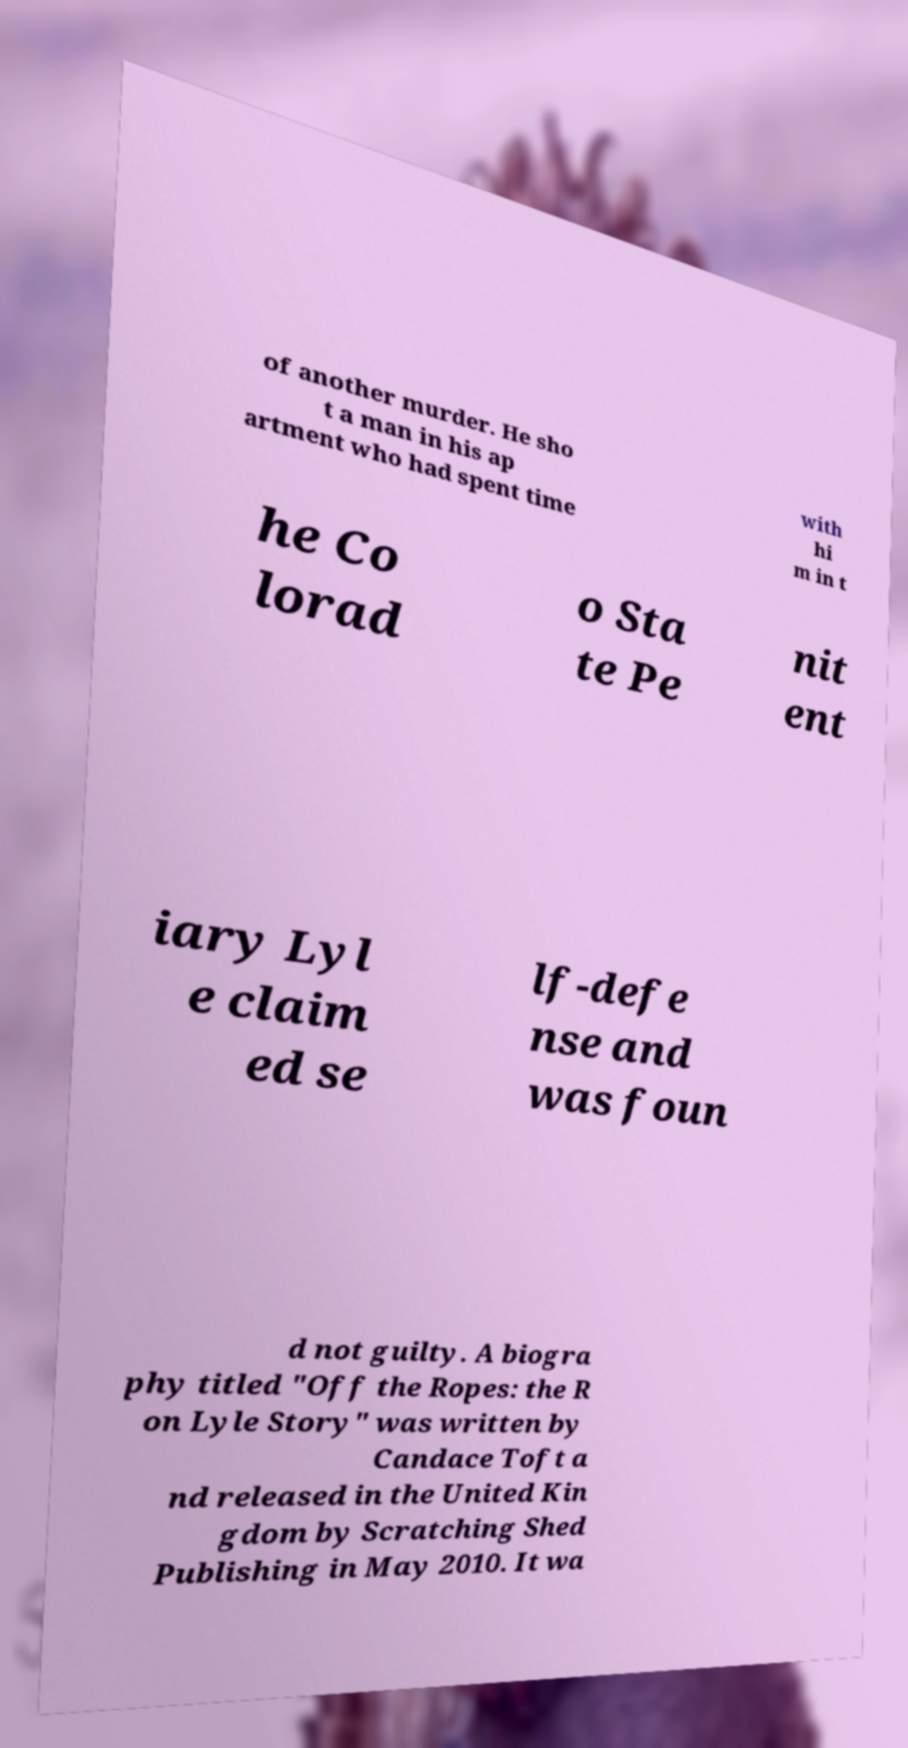For documentation purposes, I need the text within this image transcribed. Could you provide that? of another murder. He sho t a man in his ap artment who had spent time with hi m in t he Co lorad o Sta te Pe nit ent iary Lyl e claim ed se lf-defe nse and was foun d not guilty. A biogra phy titled "Off the Ropes: the R on Lyle Story" was written by Candace Toft a nd released in the United Kin gdom by Scratching Shed Publishing in May 2010. It wa 